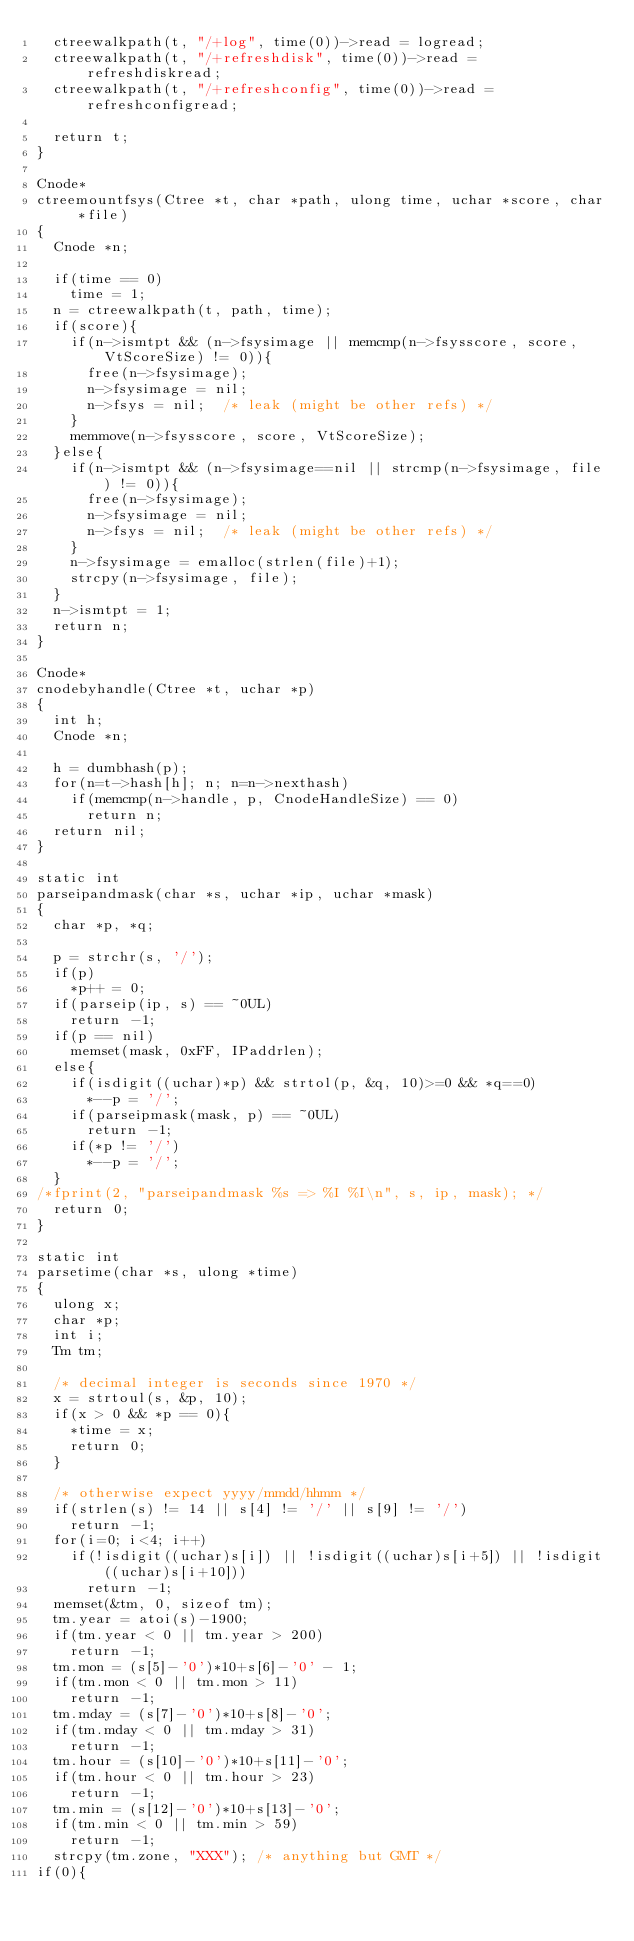Convert code to text. <code><loc_0><loc_0><loc_500><loc_500><_C_>	ctreewalkpath(t, "/+log", time(0))->read = logread;
	ctreewalkpath(t, "/+refreshdisk", time(0))->read = refreshdiskread;
	ctreewalkpath(t, "/+refreshconfig", time(0))->read = refreshconfigread;

	return t;
}

Cnode*
ctreemountfsys(Ctree *t, char *path, ulong time, uchar *score, char *file)
{
	Cnode *n;

	if(time == 0)
		time = 1;
	n = ctreewalkpath(t, path, time);
	if(score){
		if(n->ismtpt && (n->fsysimage || memcmp(n->fsysscore, score, VtScoreSize) != 0)){
			free(n->fsysimage);
			n->fsysimage = nil;
			n->fsys = nil;	/* leak (might be other refs) */
		}
		memmove(n->fsysscore, score, VtScoreSize);
	}else{
		if(n->ismtpt && (n->fsysimage==nil || strcmp(n->fsysimage, file) != 0)){
			free(n->fsysimage);
			n->fsysimage = nil;
			n->fsys = nil;	/* leak (might be other refs) */
		}
		n->fsysimage = emalloc(strlen(file)+1);
		strcpy(n->fsysimage, file);
	}
	n->ismtpt = 1;
	return n;
}

Cnode*
cnodebyhandle(Ctree *t, uchar *p)
{
	int h;
	Cnode *n;

	h = dumbhash(p);
	for(n=t->hash[h]; n; n=n->nexthash)
		if(memcmp(n->handle, p, CnodeHandleSize) == 0)
			return n;
	return nil;
}

static int
parseipandmask(char *s, uchar *ip, uchar *mask)
{
	char *p, *q;

	p = strchr(s, '/');
	if(p)
		*p++ = 0;
	if(parseip(ip, s) == ~0UL)
		return -1;
	if(p == nil)
		memset(mask, 0xFF, IPaddrlen);
	else{
		if(isdigit((uchar)*p) && strtol(p, &q, 10)>=0 && *q==0)
			*--p = '/';
		if(parseipmask(mask, p) == ~0UL)
			return -1;
		if(*p != '/')
			*--p = '/';
	}
/*fprint(2, "parseipandmask %s => %I %I\n", s, ip, mask); */
	return 0;
}

static int
parsetime(char *s, ulong *time)
{
	ulong x;
	char *p;
	int i;
	Tm tm;

	/* decimal integer is seconds since 1970 */
	x = strtoul(s, &p, 10);
	if(x > 0 && *p == 0){
		*time = x;
		return 0;
	}

	/* otherwise expect yyyy/mmdd/hhmm */
	if(strlen(s) != 14 || s[4] != '/' || s[9] != '/')
		return -1;
	for(i=0; i<4; i++)
		if(!isdigit((uchar)s[i]) || !isdigit((uchar)s[i+5]) || !isdigit((uchar)s[i+10]))
			return -1;
	memset(&tm, 0, sizeof tm);
	tm.year = atoi(s)-1900;
	if(tm.year < 0 || tm.year > 200)
		return -1;
	tm.mon = (s[5]-'0')*10+s[6]-'0' - 1;
	if(tm.mon < 0 || tm.mon > 11)
		return -1;
	tm.mday = (s[7]-'0')*10+s[8]-'0';
	if(tm.mday < 0 || tm.mday > 31)
		return -1;
	tm.hour = (s[10]-'0')*10+s[11]-'0';
	if(tm.hour < 0 || tm.hour > 23)
		return -1;
	tm.min = (s[12]-'0')*10+s[13]-'0';
	if(tm.min < 0 || tm.min > 59)
		return -1;
	strcpy(tm.zone, "XXX");	/* anything but GMT */
if(0){</code> 